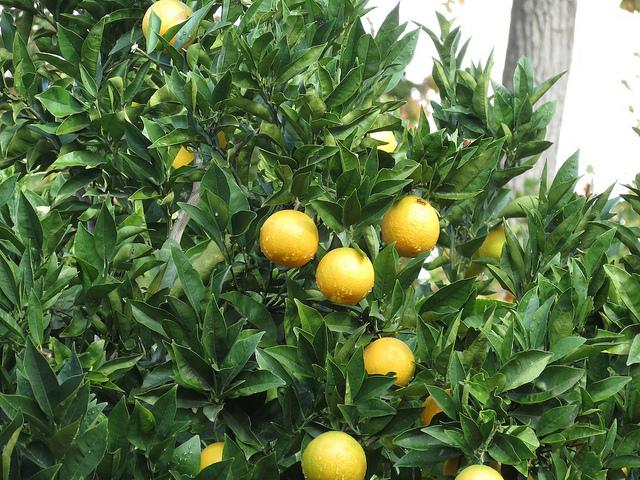What color are the fruits?
Answer briefly. Yellow. What type of tree is it?
Write a very short answer. Lemon. What kind of fruit is on the tree?
Be succinct. Oranges. Are the leaves on the tree simple or compound?
Be succinct. Simple. 